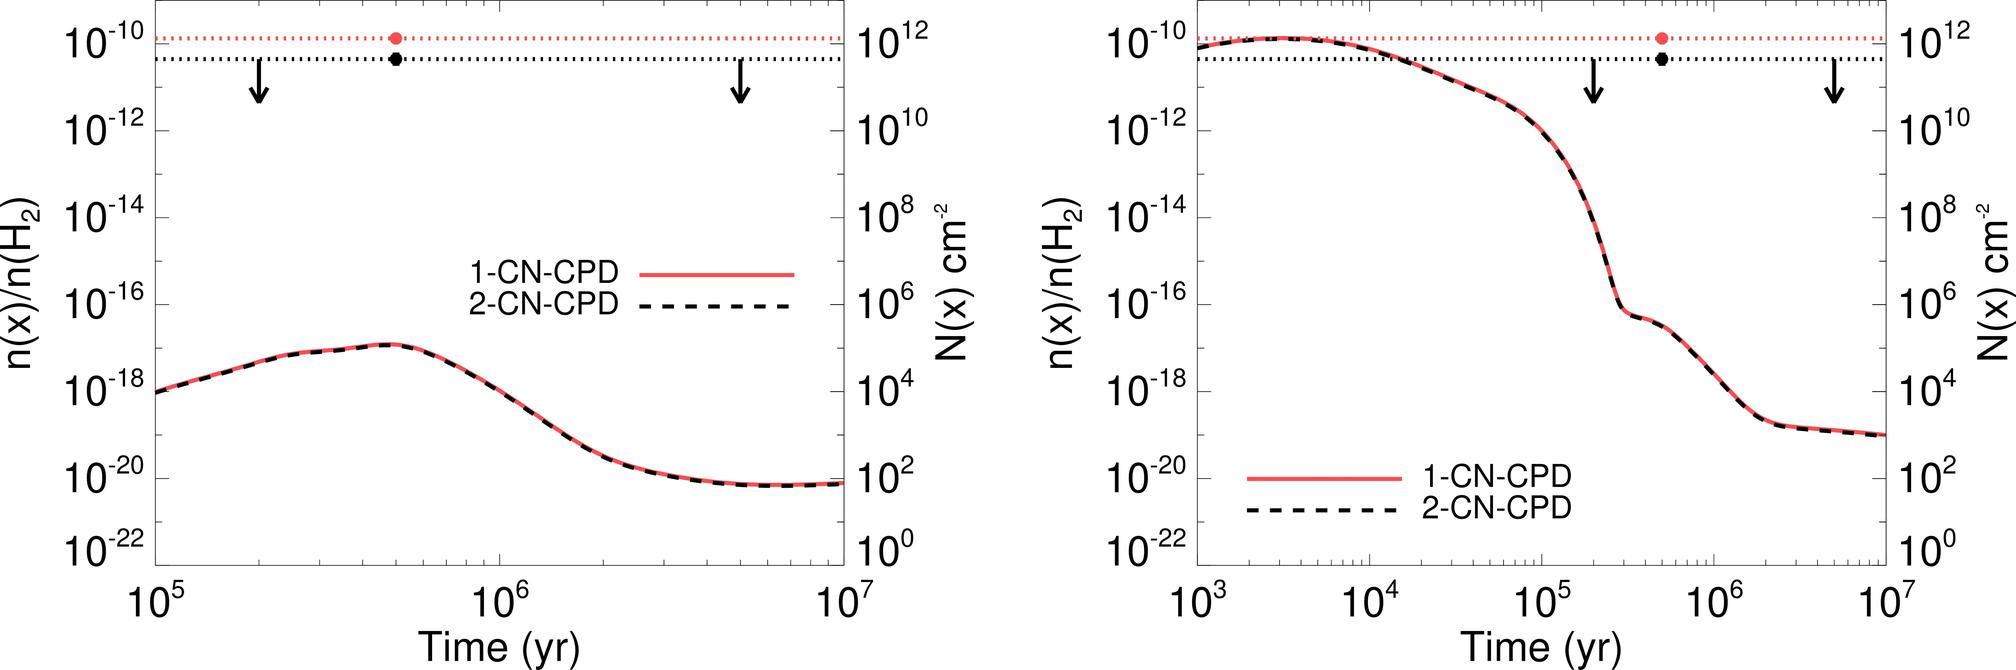What could cause such a dramatic decrease in the concentrations of these compounds? A dramatic decrease could be attributed to various physical or chemical processes such as the breakdown of the compounds due to radiation, chemical reactions altering their structure, dilution into a larger volume, or environmental changes that affect their stability. Understanding the exact cause would require more context about the conditions and the nature of these compounds. 